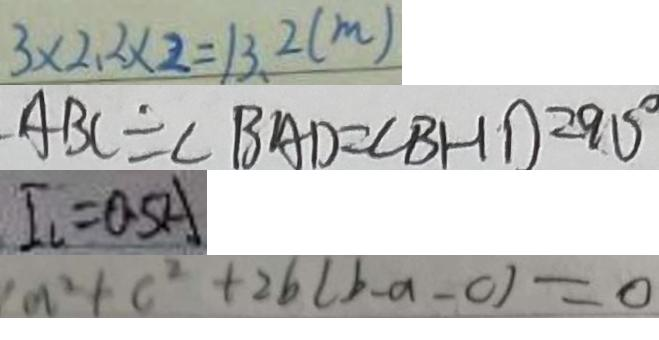<formula> <loc_0><loc_0><loc_500><loc_500>3 \times 2 . 2 \times 2 = 1 3 . 2 ( m ) 
 A B C = \angle B A D = \angle B H D = 9 0 ^ { \circ } 
 I _ { l } = 0 . 5 A 
 a ^ { 2 } + c ^ { 2 } + 2 b ( b - a - c ) = 0</formula> 